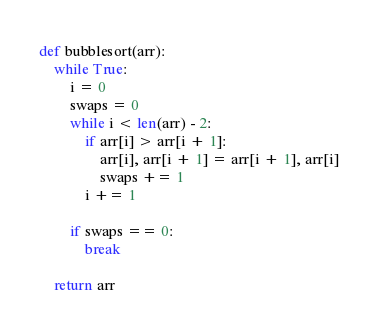Convert code to text. <code><loc_0><loc_0><loc_500><loc_500><_Python_>def bubblesort(arr):
    while True:
        i = 0
        swaps = 0
        while i < len(arr) - 2:
            if arr[i] > arr[i + 1]:
                arr[i], arr[i + 1] = arr[i + 1], arr[i]
                swaps += 1
            i += 1

        if swaps == 0:
            break

    return arr
</code> 